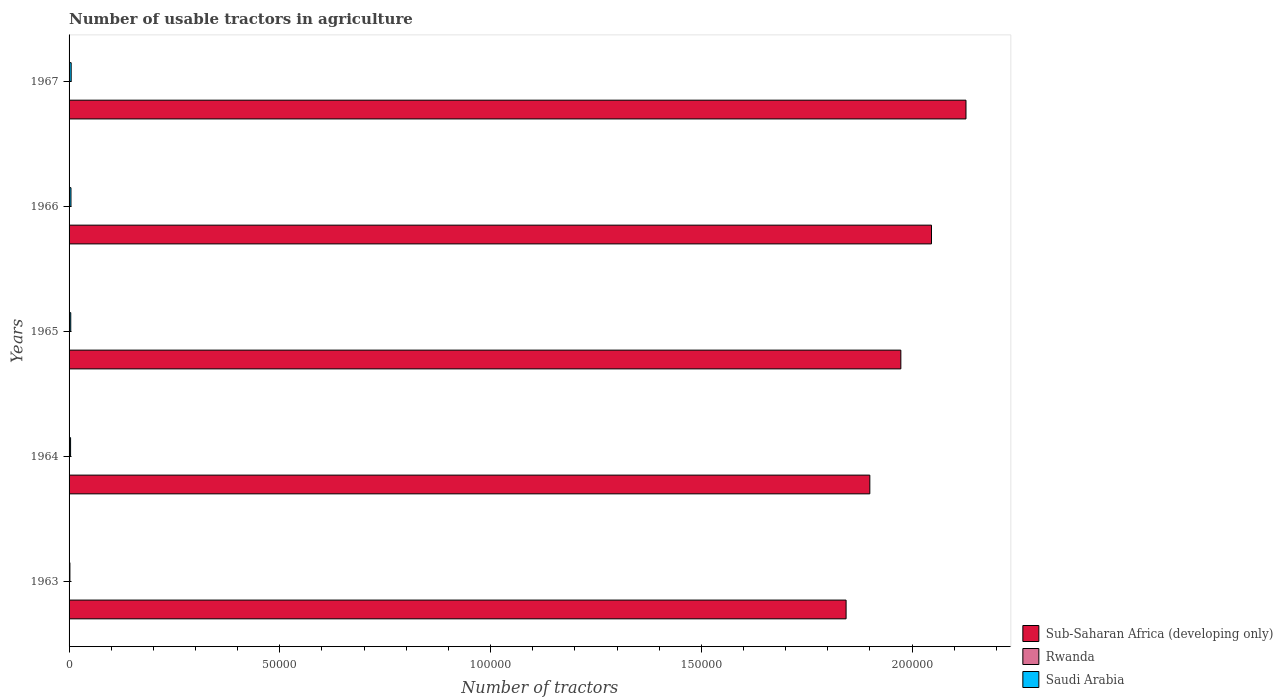How many groups of bars are there?
Your answer should be compact. 5. Are the number of bars per tick equal to the number of legend labels?
Make the answer very short. Yes. How many bars are there on the 5th tick from the top?
Offer a very short reply. 3. How many bars are there on the 1st tick from the bottom?
Provide a succinct answer. 3. What is the label of the 3rd group of bars from the top?
Provide a succinct answer. 1965. In how many cases, is the number of bars for a given year not equal to the number of legend labels?
Keep it short and to the point. 0. What is the number of usable tractors in agriculture in Sub-Saharan Africa (developing only) in 1966?
Ensure brevity in your answer.  2.05e+05. Across all years, what is the maximum number of usable tractors in agriculture in Sub-Saharan Africa (developing only)?
Your response must be concise. 2.13e+05. In which year was the number of usable tractors in agriculture in Saudi Arabia maximum?
Give a very brief answer. 1967. In which year was the number of usable tractors in agriculture in Rwanda minimum?
Offer a very short reply. 1963. What is the total number of usable tractors in agriculture in Sub-Saharan Africa (developing only) in the graph?
Make the answer very short. 9.89e+05. What is the difference between the number of usable tractors in agriculture in Saudi Arabia in 1963 and that in 1966?
Make the answer very short. -253. What is the difference between the number of usable tractors in agriculture in Sub-Saharan Africa (developing only) in 1967 and the number of usable tractors in agriculture in Saudi Arabia in 1965?
Give a very brief answer. 2.12e+05. What is the average number of usable tractors in agriculture in Rwanda per year?
Provide a succinct answer. 36.2. In the year 1963, what is the difference between the number of usable tractors in agriculture in Rwanda and number of usable tractors in agriculture in Saudi Arabia?
Keep it short and to the point. -169. In how many years, is the number of usable tractors in agriculture in Rwanda greater than 100000 ?
Provide a short and direct response. 0. What is the ratio of the number of usable tractors in agriculture in Sub-Saharan Africa (developing only) in 1964 to that in 1966?
Provide a succinct answer. 0.93. Is the difference between the number of usable tractors in agriculture in Rwanda in 1964 and 1966 greater than the difference between the number of usable tractors in agriculture in Saudi Arabia in 1964 and 1966?
Provide a succinct answer. Yes. What is the difference between the highest and the second highest number of usable tractors in agriculture in Rwanda?
Offer a very short reply. 3. What is the difference between the highest and the lowest number of usable tractors in agriculture in Saudi Arabia?
Offer a terse response. 303. In how many years, is the number of usable tractors in agriculture in Saudi Arabia greater than the average number of usable tractors in agriculture in Saudi Arabia taken over all years?
Give a very brief answer. 3. Is the sum of the number of usable tractors in agriculture in Rwanda in 1964 and 1965 greater than the maximum number of usable tractors in agriculture in Sub-Saharan Africa (developing only) across all years?
Provide a short and direct response. No. What does the 1st bar from the top in 1967 represents?
Your answer should be compact. Saudi Arabia. What does the 1st bar from the bottom in 1966 represents?
Keep it short and to the point. Sub-Saharan Africa (developing only). Is it the case that in every year, the sum of the number of usable tractors in agriculture in Rwanda and number of usable tractors in agriculture in Sub-Saharan Africa (developing only) is greater than the number of usable tractors in agriculture in Saudi Arabia?
Provide a short and direct response. Yes. Are all the bars in the graph horizontal?
Offer a terse response. Yes. How many years are there in the graph?
Make the answer very short. 5. Are the values on the major ticks of X-axis written in scientific E-notation?
Your answer should be very brief. No. Does the graph contain grids?
Offer a terse response. No. How are the legend labels stacked?
Your response must be concise. Vertical. What is the title of the graph?
Offer a terse response. Number of usable tractors in agriculture. Does "High income: OECD" appear as one of the legend labels in the graph?
Offer a very short reply. No. What is the label or title of the X-axis?
Your answer should be compact. Number of tractors. What is the Number of tractors of Sub-Saharan Africa (developing only) in 1963?
Ensure brevity in your answer.  1.84e+05. What is the Number of tractors of Rwanda in 1963?
Offer a terse response. 28. What is the Number of tractors in Saudi Arabia in 1963?
Offer a terse response. 197. What is the Number of tractors in Sub-Saharan Africa (developing only) in 1964?
Your answer should be compact. 1.90e+05. What is the Number of tractors in Saudi Arabia in 1964?
Provide a short and direct response. 357. What is the Number of tractors of Sub-Saharan Africa (developing only) in 1965?
Make the answer very short. 1.97e+05. What is the Number of tractors in Sub-Saharan Africa (developing only) in 1966?
Provide a short and direct response. 2.05e+05. What is the Number of tractors in Rwanda in 1966?
Provide a short and direct response. 40. What is the Number of tractors of Saudi Arabia in 1966?
Your answer should be compact. 450. What is the Number of tractors in Sub-Saharan Africa (developing only) in 1967?
Offer a very short reply. 2.13e+05. Across all years, what is the maximum Number of tractors of Sub-Saharan Africa (developing only)?
Make the answer very short. 2.13e+05. Across all years, what is the maximum Number of tractors of Saudi Arabia?
Ensure brevity in your answer.  500. Across all years, what is the minimum Number of tractors in Sub-Saharan Africa (developing only)?
Your answer should be compact. 1.84e+05. Across all years, what is the minimum Number of tractors in Saudi Arabia?
Keep it short and to the point. 197. What is the total Number of tractors of Sub-Saharan Africa (developing only) in the graph?
Your answer should be very brief. 9.89e+05. What is the total Number of tractors in Rwanda in the graph?
Give a very brief answer. 181. What is the total Number of tractors of Saudi Arabia in the graph?
Your answer should be very brief. 1904. What is the difference between the Number of tractors of Sub-Saharan Africa (developing only) in 1963 and that in 1964?
Make the answer very short. -5631. What is the difference between the Number of tractors in Rwanda in 1963 and that in 1964?
Your answer should be compact. -5. What is the difference between the Number of tractors in Saudi Arabia in 1963 and that in 1964?
Give a very brief answer. -160. What is the difference between the Number of tractors of Sub-Saharan Africa (developing only) in 1963 and that in 1965?
Your response must be concise. -1.30e+04. What is the difference between the Number of tractors in Rwanda in 1963 and that in 1965?
Provide a succinct answer. -9. What is the difference between the Number of tractors of Saudi Arabia in 1963 and that in 1965?
Make the answer very short. -203. What is the difference between the Number of tractors in Sub-Saharan Africa (developing only) in 1963 and that in 1966?
Your response must be concise. -2.03e+04. What is the difference between the Number of tractors of Rwanda in 1963 and that in 1966?
Provide a succinct answer. -12. What is the difference between the Number of tractors of Saudi Arabia in 1963 and that in 1966?
Offer a terse response. -253. What is the difference between the Number of tractors in Sub-Saharan Africa (developing only) in 1963 and that in 1967?
Provide a short and direct response. -2.84e+04. What is the difference between the Number of tractors in Rwanda in 1963 and that in 1967?
Offer a terse response. -15. What is the difference between the Number of tractors of Saudi Arabia in 1963 and that in 1967?
Your answer should be very brief. -303. What is the difference between the Number of tractors in Sub-Saharan Africa (developing only) in 1964 and that in 1965?
Give a very brief answer. -7357. What is the difference between the Number of tractors of Rwanda in 1964 and that in 1965?
Give a very brief answer. -4. What is the difference between the Number of tractors of Saudi Arabia in 1964 and that in 1965?
Your response must be concise. -43. What is the difference between the Number of tractors of Sub-Saharan Africa (developing only) in 1964 and that in 1966?
Offer a very short reply. -1.46e+04. What is the difference between the Number of tractors in Saudi Arabia in 1964 and that in 1966?
Your response must be concise. -93. What is the difference between the Number of tractors in Sub-Saharan Africa (developing only) in 1964 and that in 1967?
Give a very brief answer. -2.28e+04. What is the difference between the Number of tractors in Saudi Arabia in 1964 and that in 1967?
Give a very brief answer. -143. What is the difference between the Number of tractors in Sub-Saharan Africa (developing only) in 1965 and that in 1966?
Your answer should be very brief. -7270. What is the difference between the Number of tractors in Saudi Arabia in 1965 and that in 1966?
Your answer should be compact. -50. What is the difference between the Number of tractors of Sub-Saharan Africa (developing only) in 1965 and that in 1967?
Provide a short and direct response. -1.55e+04. What is the difference between the Number of tractors of Rwanda in 1965 and that in 1967?
Make the answer very short. -6. What is the difference between the Number of tractors in Saudi Arabia in 1965 and that in 1967?
Provide a succinct answer. -100. What is the difference between the Number of tractors of Sub-Saharan Africa (developing only) in 1966 and that in 1967?
Provide a succinct answer. -8186. What is the difference between the Number of tractors in Sub-Saharan Africa (developing only) in 1963 and the Number of tractors in Rwanda in 1964?
Keep it short and to the point. 1.84e+05. What is the difference between the Number of tractors of Sub-Saharan Africa (developing only) in 1963 and the Number of tractors of Saudi Arabia in 1964?
Ensure brevity in your answer.  1.84e+05. What is the difference between the Number of tractors in Rwanda in 1963 and the Number of tractors in Saudi Arabia in 1964?
Your answer should be very brief. -329. What is the difference between the Number of tractors of Sub-Saharan Africa (developing only) in 1963 and the Number of tractors of Rwanda in 1965?
Ensure brevity in your answer.  1.84e+05. What is the difference between the Number of tractors of Sub-Saharan Africa (developing only) in 1963 and the Number of tractors of Saudi Arabia in 1965?
Your response must be concise. 1.84e+05. What is the difference between the Number of tractors in Rwanda in 1963 and the Number of tractors in Saudi Arabia in 1965?
Provide a succinct answer. -372. What is the difference between the Number of tractors of Sub-Saharan Africa (developing only) in 1963 and the Number of tractors of Rwanda in 1966?
Ensure brevity in your answer.  1.84e+05. What is the difference between the Number of tractors in Sub-Saharan Africa (developing only) in 1963 and the Number of tractors in Saudi Arabia in 1966?
Your answer should be compact. 1.84e+05. What is the difference between the Number of tractors in Rwanda in 1963 and the Number of tractors in Saudi Arabia in 1966?
Provide a short and direct response. -422. What is the difference between the Number of tractors in Sub-Saharan Africa (developing only) in 1963 and the Number of tractors in Rwanda in 1967?
Your answer should be compact. 1.84e+05. What is the difference between the Number of tractors in Sub-Saharan Africa (developing only) in 1963 and the Number of tractors in Saudi Arabia in 1967?
Provide a succinct answer. 1.84e+05. What is the difference between the Number of tractors in Rwanda in 1963 and the Number of tractors in Saudi Arabia in 1967?
Provide a succinct answer. -472. What is the difference between the Number of tractors of Sub-Saharan Africa (developing only) in 1964 and the Number of tractors of Rwanda in 1965?
Provide a short and direct response. 1.90e+05. What is the difference between the Number of tractors of Sub-Saharan Africa (developing only) in 1964 and the Number of tractors of Saudi Arabia in 1965?
Keep it short and to the point. 1.90e+05. What is the difference between the Number of tractors of Rwanda in 1964 and the Number of tractors of Saudi Arabia in 1965?
Your answer should be compact. -367. What is the difference between the Number of tractors in Sub-Saharan Africa (developing only) in 1964 and the Number of tractors in Rwanda in 1966?
Offer a terse response. 1.90e+05. What is the difference between the Number of tractors in Sub-Saharan Africa (developing only) in 1964 and the Number of tractors in Saudi Arabia in 1966?
Your answer should be very brief. 1.90e+05. What is the difference between the Number of tractors of Rwanda in 1964 and the Number of tractors of Saudi Arabia in 1966?
Provide a short and direct response. -417. What is the difference between the Number of tractors of Sub-Saharan Africa (developing only) in 1964 and the Number of tractors of Rwanda in 1967?
Keep it short and to the point. 1.90e+05. What is the difference between the Number of tractors of Sub-Saharan Africa (developing only) in 1964 and the Number of tractors of Saudi Arabia in 1967?
Your answer should be very brief. 1.89e+05. What is the difference between the Number of tractors of Rwanda in 1964 and the Number of tractors of Saudi Arabia in 1967?
Keep it short and to the point. -467. What is the difference between the Number of tractors of Sub-Saharan Africa (developing only) in 1965 and the Number of tractors of Rwanda in 1966?
Your response must be concise. 1.97e+05. What is the difference between the Number of tractors in Sub-Saharan Africa (developing only) in 1965 and the Number of tractors in Saudi Arabia in 1966?
Keep it short and to the point. 1.97e+05. What is the difference between the Number of tractors of Rwanda in 1965 and the Number of tractors of Saudi Arabia in 1966?
Provide a succinct answer. -413. What is the difference between the Number of tractors in Sub-Saharan Africa (developing only) in 1965 and the Number of tractors in Rwanda in 1967?
Your answer should be very brief. 1.97e+05. What is the difference between the Number of tractors in Sub-Saharan Africa (developing only) in 1965 and the Number of tractors in Saudi Arabia in 1967?
Offer a very short reply. 1.97e+05. What is the difference between the Number of tractors of Rwanda in 1965 and the Number of tractors of Saudi Arabia in 1967?
Your response must be concise. -463. What is the difference between the Number of tractors in Sub-Saharan Africa (developing only) in 1966 and the Number of tractors in Rwanda in 1967?
Offer a very short reply. 2.05e+05. What is the difference between the Number of tractors in Sub-Saharan Africa (developing only) in 1966 and the Number of tractors in Saudi Arabia in 1967?
Ensure brevity in your answer.  2.04e+05. What is the difference between the Number of tractors in Rwanda in 1966 and the Number of tractors in Saudi Arabia in 1967?
Your answer should be very brief. -460. What is the average Number of tractors of Sub-Saharan Africa (developing only) per year?
Offer a very short reply. 1.98e+05. What is the average Number of tractors of Rwanda per year?
Your answer should be compact. 36.2. What is the average Number of tractors in Saudi Arabia per year?
Your answer should be very brief. 380.8. In the year 1963, what is the difference between the Number of tractors of Sub-Saharan Africa (developing only) and Number of tractors of Rwanda?
Offer a terse response. 1.84e+05. In the year 1963, what is the difference between the Number of tractors in Sub-Saharan Africa (developing only) and Number of tractors in Saudi Arabia?
Your answer should be very brief. 1.84e+05. In the year 1963, what is the difference between the Number of tractors in Rwanda and Number of tractors in Saudi Arabia?
Ensure brevity in your answer.  -169. In the year 1964, what is the difference between the Number of tractors in Sub-Saharan Africa (developing only) and Number of tractors in Rwanda?
Keep it short and to the point. 1.90e+05. In the year 1964, what is the difference between the Number of tractors of Sub-Saharan Africa (developing only) and Number of tractors of Saudi Arabia?
Your response must be concise. 1.90e+05. In the year 1964, what is the difference between the Number of tractors in Rwanda and Number of tractors in Saudi Arabia?
Your response must be concise. -324. In the year 1965, what is the difference between the Number of tractors in Sub-Saharan Africa (developing only) and Number of tractors in Rwanda?
Provide a succinct answer. 1.97e+05. In the year 1965, what is the difference between the Number of tractors in Sub-Saharan Africa (developing only) and Number of tractors in Saudi Arabia?
Provide a short and direct response. 1.97e+05. In the year 1965, what is the difference between the Number of tractors in Rwanda and Number of tractors in Saudi Arabia?
Your answer should be very brief. -363. In the year 1966, what is the difference between the Number of tractors in Sub-Saharan Africa (developing only) and Number of tractors in Rwanda?
Your answer should be very brief. 2.05e+05. In the year 1966, what is the difference between the Number of tractors in Sub-Saharan Africa (developing only) and Number of tractors in Saudi Arabia?
Offer a very short reply. 2.04e+05. In the year 1966, what is the difference between the Number of tractors in Rwanda and Number of tractors in Saudi Arabia?
Provide a succinct answer. -410. In the year 1967, what is the difference between the Number of tractors in Sub-Saharan Africa (developing only) and Number of tractors in Rwanda?
Offer a terse response. 2.13e+05. In the year 1967, what is the difference between the Number of tractors of Sub-Saharan Africa (developing only) and Number of tractors of Saudi Arabia?
Give a very brief answer. 2.12e+05. In the year 1967, what is the difference between the Number of tractors of Rwanda and Number of tractors of Saudi Arabia?
Provide a short and direct response. -457. What is the ratio of the Number of tractors of Sub-Saharan Africa (developing only) in 1963 to that in 1964?
Provide a succinct answer. 0.97. What is the ratio of the Number of tractors of Rwanda in 1963 to that in 1964?
Your answer should be compact. 0.85. What is the ratio of the Number of tractors in Saudi Arabia in 1963 to that in 1964?
Provide a short and direct response. 0.55. What is the ratio of the Number of tractors of Sub-Saharan Africa (developing only) in 1963 to that in 1965?
Provide a short and direct response. 0.93. What is the ratio of the Number of tractors in Rwanda in 1963 to that in 1965?
Ensure brevity in your answer.  0.76. What is the ratio of the Number of tractors of Saudi Arabia in 1963 to that in 1965?
Offer a very short reply. 0.49. What is the ratio of the Number of tractors of Sub-Saharan Africa (developing only) in 1963 to that in 1966?
Offer a very short reply. 0.9. What is the ratio of the Number of tractors of Saudi Arabia in 1963 to that in 1966?
Keep it short and to the point. 0.44. What is the ratio of the Number of tractors of Sub-Saharan Africa (developing only) in 1963 to that in 1967?
Make the answer very short. 0.87. What is the ratio of the Number of tractors in Rwanda in 1963 to that in 1967?
Give a very brief answer. 0.65. What is the ratio of the Number of tractors of Saudi Arabia in 1963 to that in 1967?
Your answer should be compact. 0.39. What is the ratio of the Number of tractors in Sub-Saharan Africa (developing only) in 1964 to that in 1965?
Your answer should be very brief. 0.96. What is the ratio of the Number of tractors in Rwanda in 1964 to that in 1965?
Provide a short and direct response. 0.89. What is the ratio of the Number of tractors of Saudi Arabia in 1964 to that in 1965?
Make the answer very short. 0.89. What is the ratio of the Number of tractors of Sub-Saharan Africa (developing only) in 1964 to that in 1966?
Give a very brief answer. 0.93. What is the ratio of the Number of tractors in Rwanda in 1964 to that in 1966?
Give a very brief answer. 0.82. What is the ratio of the Number of tractors in Saudi Arabia in 1964 to that in 1966?
Give a very brief answer. 0.79. What is the ratio of the Number of tractors of Sub-Saharan Africa (developing only) in 1964 to that in 1967?
Offer a very short reply. 0.89. What is the ratio of the Number of tractors of Rwanda in 1964 to that in 1967?
Your response must be concise. 0.77. What is the ratio of the Number of tractors in Saudi Arabia in 1964 to that in 1967?
Provide a succinct answer. 0.71. What is the ratio of the Number of tractors of Sub-Saharan Africa (developing only) in 1965 to that in 1966?
Your answer should be very brief. 0.96. What is the ratio of the Number of tractors in Rwanda in 1965 to that in 1966?
Provide a short and direct response. 0.93. What is the ratio of the Number of tractors of Saudi Arabia in 1965 to that in 1966?
Your response must be concise. 0.89. What is the ratio of the Number of tractors in Sub-Saharan Africa (developing only) in 1965 to that in 1967?
Offer a terse response. 0.93. What is the ratio of the Number of tractors in Rwanda in 1965 to that in 1967?
Your response must be concise. 0.86. What is the ratio of the Number of tractors of Saudi Arabia in 1965 to that in 1967?
Ensure brevity in your answer.  0.8. What is the ratio of the Number of tractors in Sub-Saharan Africa (developing only) in 1966 to that in 1967?
Your answer should be compact. 0.96. What is the ratio of the Number of tractors in Rwanda in 1966 to that in 1967?
Ensure brevity in your answer.  0.93. What is the difference between the highest and the second highest Number of tractors of Sub-Saharan Africa (developing only)?
Provide a succinct answer. 8186. What is the difference between the highest and the second highest Number of tractors in Saudi Arabia?
Keep it short and to the point. 50. What is the difference between the highest and the lowest Number of tractors of Sub-Saharan Africa (developing only)?
Your answer should be compact. 2.84e+04. What is the difference between the highest and the lowest Number of tractors in Saudi Arabia?
Provide a short and direct response. 303. 